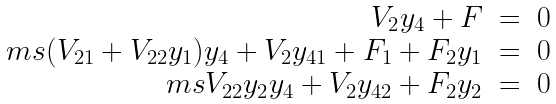<formula> <loc_0><loc_0><loc_500><loc_500>\begin{array} { r l l } V _ { 2 } y _ { 4 } + F & = & 0 \\ { \ m s } ( V _ { 2 1 } + V _ { 2 2 } y _ { 1 } ) y _ { 4 } + V _ { 2 } y _ { 4 1 } + F _ { 1 } + F _ { 2 } y _ { 1 } & = & 0 \\ { \ m s } V _ { 2 2 } y _ { 2 } y _ { 4 } + V _ { 2 } y _ { 4 2 } + F _ { 2 } y _ { 2 } & = & 0 \\ \end{array}</formula> 